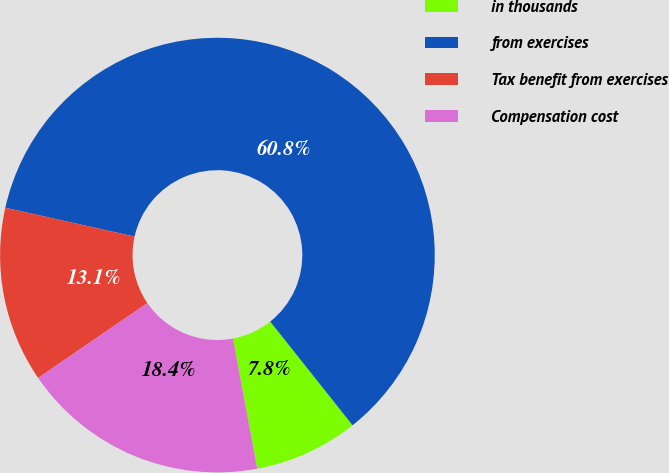Convert chart to OTSL. <chart><loc_0><loc_0><loc_500><loc_500><pie_chart><fcel>in thousands<fcel>from exercises<fcel>Tax benefit from exercises<fcel>Compensation cost<nl><fcel>7.75%<fcel>60.82%<fcel>13.06%<fcel>18.37%<nl></chart> 